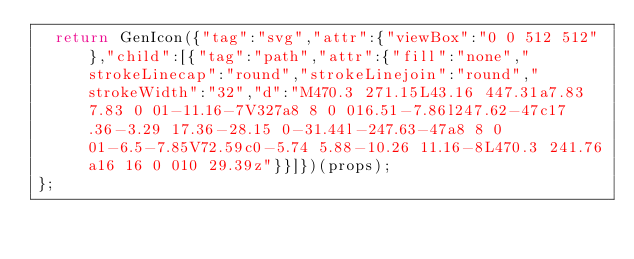<code> <loc_0><loc_0><loc_500><loc_500><_JavaScript_>  return GenIcon({"tag":"svg","attr":{"viewBox":"0 0 512 512"},"child":[{"tag":"path","attr":{"fill":"none","strokeLinecap":"round","strokeLinejoin":"round","strokeWidth":"32","d":"M470.3 271.15L43.16 447.31a7.83 7.83 0 01-11.16-7V327a8 8 0 016.51-7.86l247.62-47c17.36-3.29 17.36-28.15 0-31.44l-247.63-47a8 8 0 01-6.5-7.85V72.59c0-5.74 5.88-10.26 11.16-8L470.3 241.76a16 16 0 010 29.39z"}}]})(props);
};
</code> 